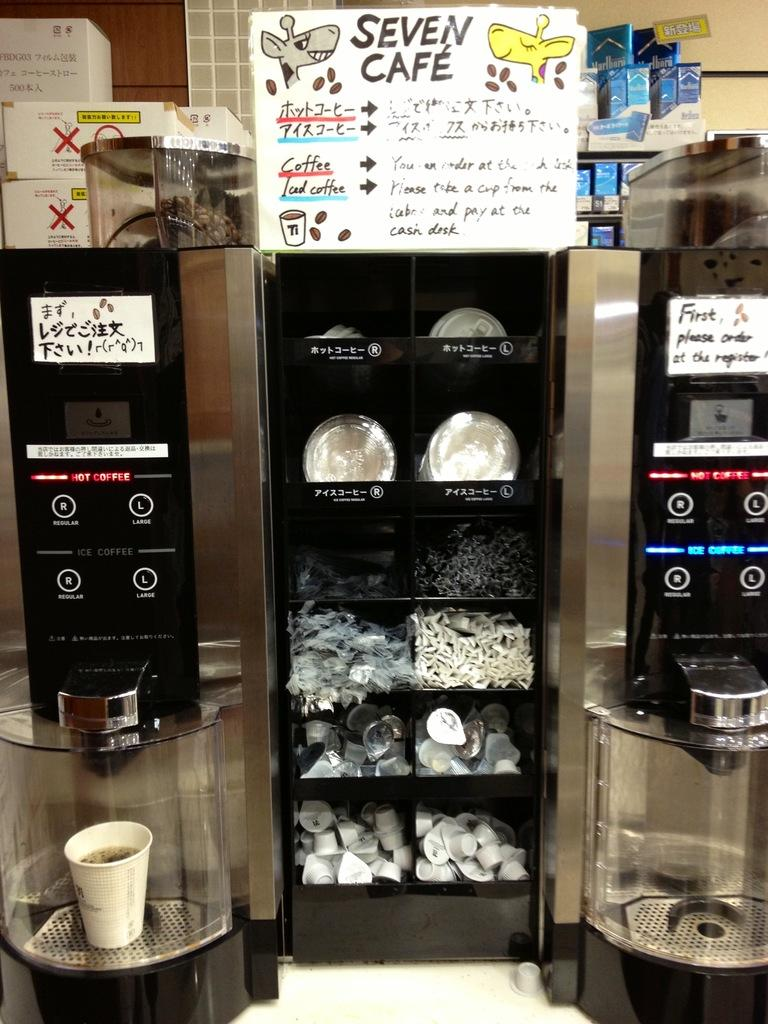<image>
Write a terse but informative summary of the picture. Coffee Makers and supplies in the Seven Cafe. 